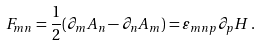<formula> <loc_0><loc_0><loc_500><loc_500>F _ { m n } = \frac { 1 } { 2 } ( \partial _ { m } A _ { n } - \partial _ { n } A _ { m } ) = \varepsilon _ { m n p } \partial _ { p } H \, .</formula> 